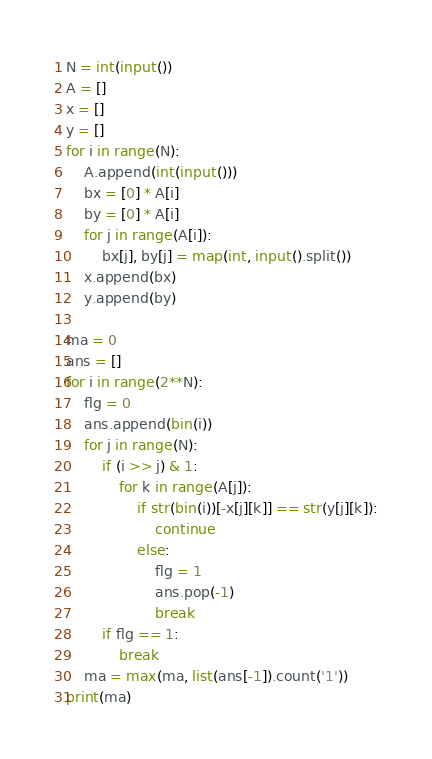<code> <loc_0><loc_0><loc_500><loc_500><_Python_>N = int(input())
A = []
x = []
y = []
for i in range(N):
    A.append(int(input()))
    bx = [0] * A[i]
    by = [0] * A[i]
    for j in range(A[i]):
        bx[j], by[j] = map(int, input().split())
    x.append(bx)
    y.append(by)

ma = 0
ans = []
for i in range(2**N):
    flg = 0
    ans.append(bin(i))
    for j in range(N):
        if (i >> j) & 1:
            for k in range(A[j]):
                if str(bin(i))[-x[j][k]] == str(y[j][k]):
                    continue
                else:
                    flg = 1
                    ans.pop(-1)
                    break
        if flg == 1:
            break
    ma = max(ma, list(ans[-1]).count('1'))
print(ma)</code> 